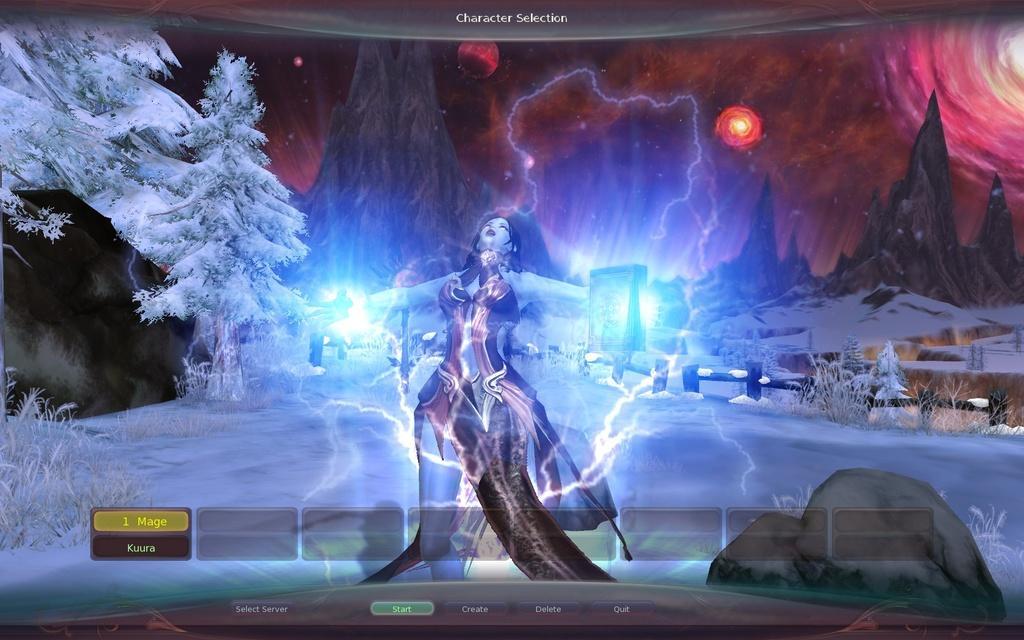Describe this image in one or two sentences. It is an edited image, in the middle a woman is there. On the left side there are trees with the snow. 